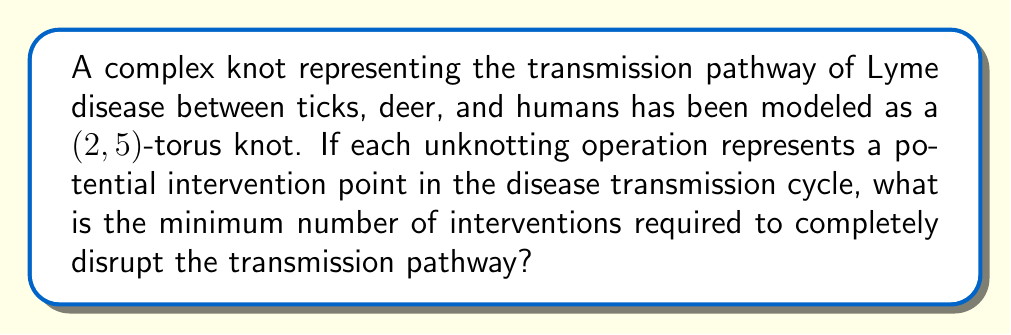Help me with this question. Let's approach this step-by-step:

1) The $(2,5)$-torus knot is also known as the cinquefoil knot.

2) The unknotting number of a knot is the minimum number of crossing changes needed to transform the knot into an unknot (trivial knot).

3) For torus knots, there's a theorem that states: The unknotting number $u(T_{p,q})$ of a $(p,q)$-torus knot is given by:

   $$u(T_{p,q}) = \frac{(p-1)(q-1)}{2}$$

4) In our case, $p=2$ and $q=5$. Let's substitute these values:

   $$u(T_{2,5}) = \frac{(2-1)(5-1)}{2}$$

5) Simplify:
   $$u(T_{2,5}) = \frac{1 \cdot 4}{2} = \frac{4}{2} = 2$$

6) Therefore, the unknotting number of the $(2,5)$-torus knot is 2.

7) In the context of the disease transmission, this means that a minimum of 2 intervention points are required to completely disrupt the transmission pathway.
Answer: 2 